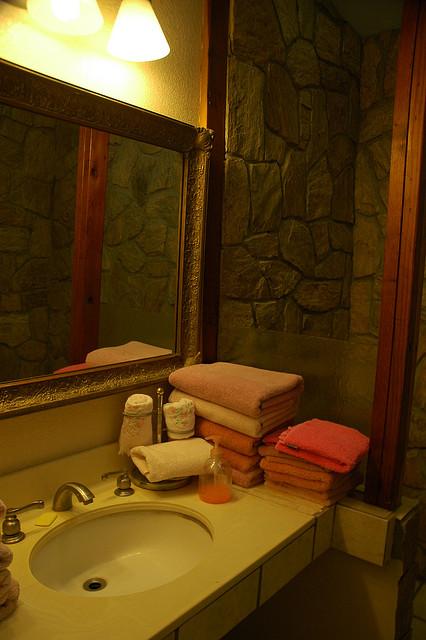How many towels are there?
Short answer required. 9. What are the walls made from?
Quick response, please. Stone. Are all the towels the same size and color?
Quick response, please. No. 